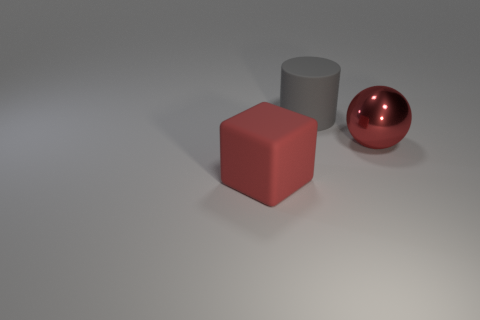Are there any other things that are the same shape as the red metallic thing?
Provide a short and direct response. No. Is there anything else that is made of the same material as the ball?
Your answer should be compact. No. What color is the matte thing that is behind the big ball?
Your answer should be very brief. Gray. Is the number of large red things that are in front of the big red metallic sphere greater than the number of small blue matte objects?
Provide a succinct answer. Yes. There is a shiny sphere; how many large metal balls are behind it?
Offer a very short reply. 0. Are there the same number of matte things that are left of the gray object and big shiny things on the right side of the big block?
Your answer should be compact. Yes. The red object that is to the left of the red ball has what shape?
Your answer should be compact. Cube. Is the big red thing on the right side of the large cylinder made of the same material as the large red object on the left side of the large rubber cylinder?
Ensure brevity in your answer.  No. The big red matte object has what shape?
Make the answer very short. Cube. Are there an equal number of large red spheres that are in front of the big red block and large rubber cylinders?
Your response must be concise. No. 